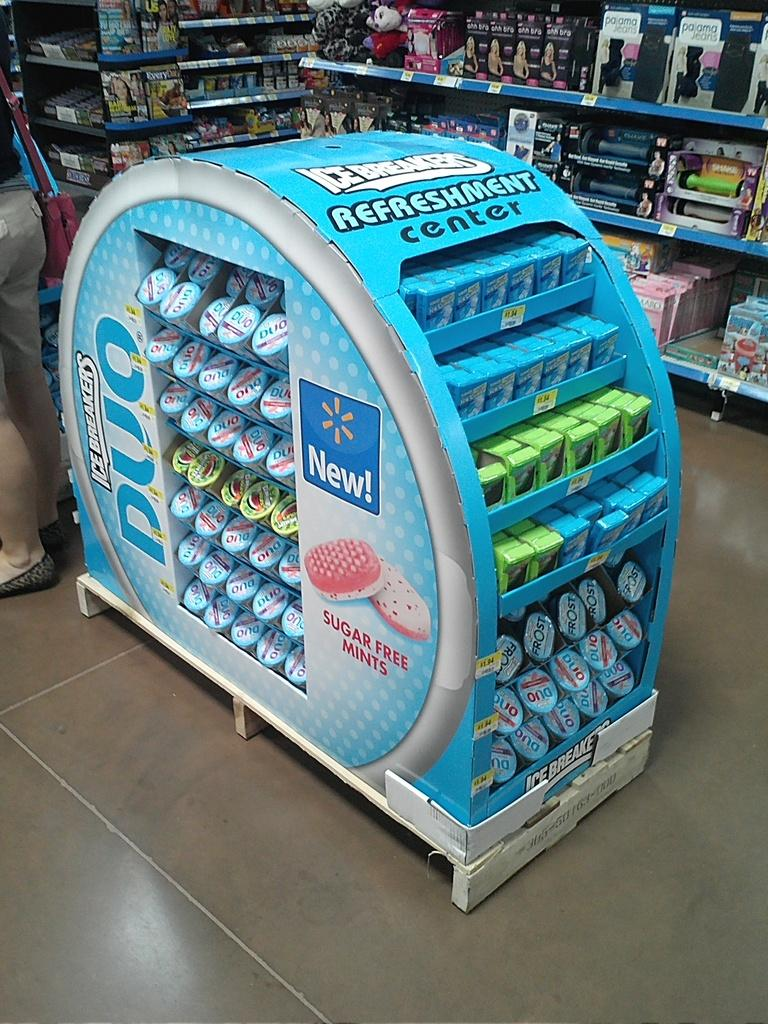Provide a one-sentence caption for the provided image. An Icebreakers gum display named Refreshment Center in a convenience store. 